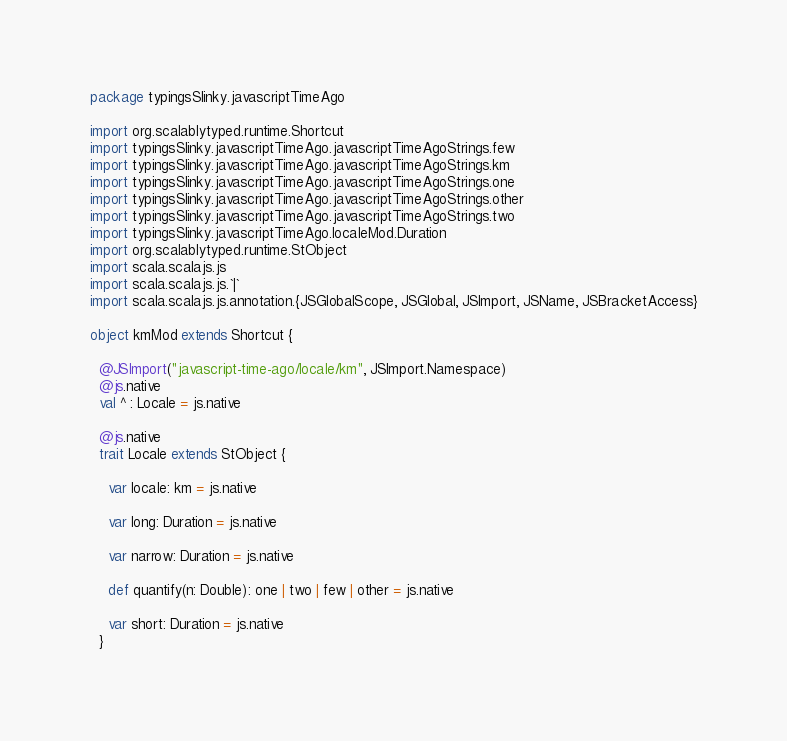<code> <loc_0><loc_0><loc_500><loc_500><_Scala_>package typingsSlinky.javascriptTimeAgo

import org.scalablytyped.runtime.Shortcut
import typingsSlinky.javascriptTimeAgo.javascriptTimeAgoStrings.few
import typingsSlinky.javascriptTimeAgo.javascriptTimeAgoStrings.km
import typingsSlinky.javascriptTimeAgo.javascriptTimeAgoStrings.one
import typingsSlinky.javascriptTimeAgo.javascriptTimeAgoStrings.other
import typingsSlinky.javascriptTimeAgo.javascriptTimeAgoStrings.two
import typingsSlinky.javascriptTimeAgo.localeMod.Duration
import org.scalablytyped.runtime.StObject
import scala.scalajs.js
import scala.scalajs.js.`|`
import scala.scalajs.js.annotation.{JSGlobalScope, JSGlobal, JSImport, JSName, JSBracketAccess}

object kmMod extends Shortcut {
  
  @JSImport("javascript-time-ago/locale/km", JSImport.Namespace)
  @js.native
  val ^ : Locale = js.native
  
  @js.native
  trait Locale extends StObject {
    
    var locale: km = js.native
    
    var long: Duration = js.native
    
    var narrow: Duration = js.native
    
    def quantify(n: Double): one | two | few | other = js.native
    
    var short: Duration = js.native
  }</code> 